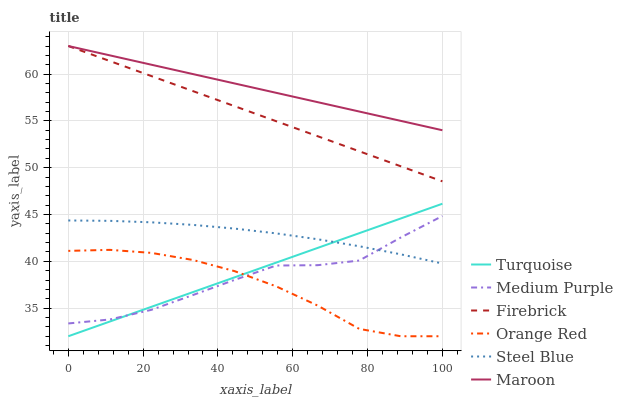Does Orange Red have the minimum area under the curve?
Answer yes or no. Yes. Does Maroon have the maximum area under the curve?
Answer yes or no. Yes. Does Firebrick have the minimum area under the curve?
Answer yes or no. No. Does Firebrick have the maximum area under the curve?
Answer yes or no. No. Is Maroon the smoothest?
Answer yes or no. Yes. Is Medium Purple the roughest?
Answer yes or no. Yes. Is Firebrick the smoothest?
Answer yes or no. No. Is Firebrick the roughest?
Answer yes or no. No. Does Turquoise have the lowest value?
Answer yes or no. Yes. Does Firebrick have the lowest value?
Answer yes or no. No. Does Maroon have the highest value?
Answer yes or no. Yes. Does Steel Blue have the highest value?
Answer yes or no. No. Is Medium Purple less than Maroon?
Answer yes or no. Yes. Is Maroon greater than Turquoise?
Answer yes or no. Yes. Does Orange Red intersect Turquoise?
Answer yes or no. Yes. Is Orange Red less than Turquoise?
Answer yes or no. No. Is Orange Red greater than Turquoise?
Answer yes or no. No. Does Medium Purple intersect Maroon?
Answer yes or no. No. 